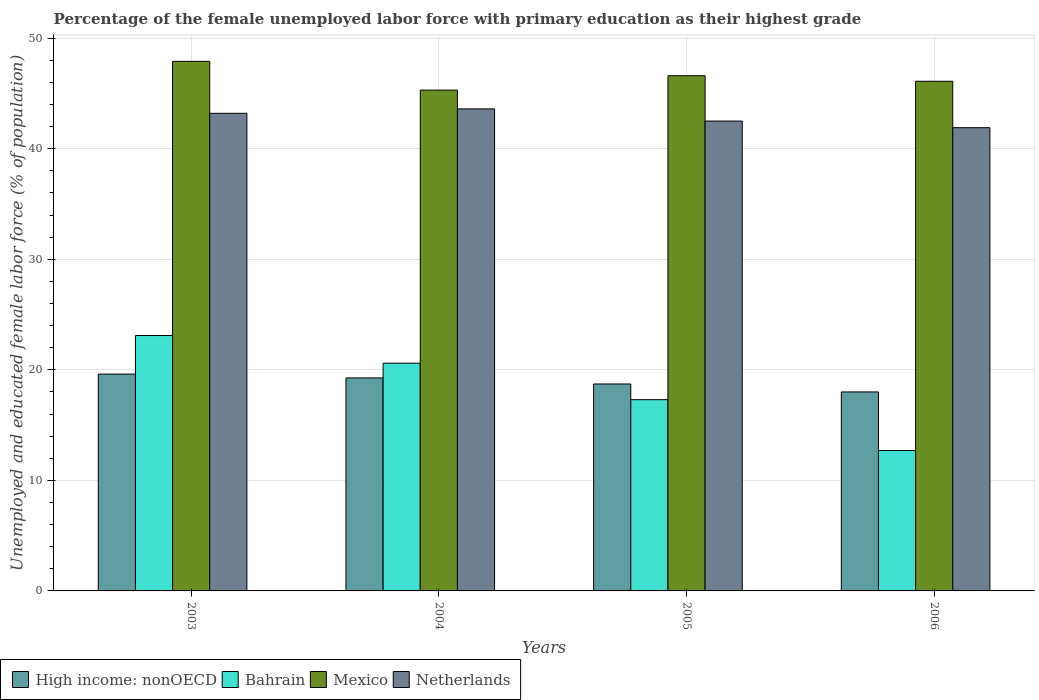How many different coloured bars are there?
Make the answer very short. 4. How many groups of bars are there?
Your response must be concise. 4. Are the number of bars per tick equal to the number of legend labels?
Give a very brief answer. Yes. Are the number of bars on each tick of the X-axis equal?
Give a very brief answer. Yes. How many bars are there on the 2nd tick from the left?
Ensure brevity in your answer.  4. How many bars are there on the 3rd tick from the right?
Your answer should be very brief. 4. What is the label of the 4th group of bars from the left?
Offer a terse response. 2006. In how many cases, is the number of bars for a given year not equal to the number of legend labels?
Your response must be concise. 0. What is the percentage of the unemployed female labor force with primary education in Netherlands in 2004?
Your response must be concise. 43.6. Across all years, what is the maximum percentage of the unemployed female labor force with primary education in Bahrain?
Offer a terse response. 23.1. Across all years, what is the minimum percentage of the unemployed female labor force with primary education in Netherlands?
Your answer should be very brief. 41.9. In which year was the percentage of the unemployed female labor force with primary education in Mexico minimum?
Offer a terse response. 2004. What is the total percentage of the unemployed female labor force with primary education in Mexico in the graph?
Offer a terse response. 185.9. What is the difference between the percentage of the unemployed female labor force with primary education in Netherlands in 2003 and that in 2005?
Ensure brevity in your answer.  0.7. What is the difference between the percentage of the unemployed female labor force with primary education in Mexico in 2005 and the percentage of the unemployed female labor force with primary education in Bahrain in 2003?
Provide a short and direct response. 23.5. What is the average percentage of the unemployed female labor force with primary education in High income: nonOECD per year?
Offer a very short reply. 18.9. In the year 2005, what is the difference between the percentage of the unemployed female labor force with primary education in High income: nonOECD and percentage of the unemployed female labor force with primary education in Netherlands?
Provide a short and direct response. -23.78. What is the ratio of the percentage of the unemployed female labor force with primary education in Bahrain in 2005 to that in 2006?
Offer a very short reply. 1.36. Is the percentage of the unemployed female labor force with primary education in High income: nonOECD in 2004 less than that in 2006?
Your answer should be very brief. No. What is the difference between the highest and the second highest percentage of the unemployed female labor force with primary education in Netherlands?
Provide a short and direct response. 0.4. What is the difference between the highest and the lowest percentage of the unemployed female labor force with primary education in Bahrain?
Your answer should be very brief. 10.4. In how many years, is the percentage of the unemployed female labor force with primary education in Netherlands greater than the average percentage of the unemployed female labor force with primary education in Netherlands taken over all years?
Keep it short and to the point. 2. Is the sum of the percentage of the unemployed female labor force with primary education in Netherlands in 2003 and 2005 greater than the maximum percentage of the unemployed female labor force with primary education in High income: nonOECD across all years?
Offer a very short reply. Yes. What does the 1st bar from the left in 2003 represents?
Your answer should be compact. High income: nonOECD. What does the 4th bar from the right in 2004 represents?
Ensure brevity in your answer.  High income: nonOECD. How many years are there in the graph?
Offer a very short reply. 4. Are the values on the major ticks of Y-axis written in scientific E-notation?
Give a very brief answer. No. Does the graph contain any zero values?
Your answer should be compact. No. How many legend labels are there?
Provide a succinct answer. 4. How are the legend labels stacked?
Give a very brief answer. Horizontal. What is the title of the graph?
Provide a succinct answer. Percentage of the female unemployed labor force with primary education as their highest grade. What is the label or title of the X-axis?
Your answer should be compact. Years. What is the label or title of the Y-axis?
Make the answer very short. Unemployed and educated female labor force (% of population). What is the Unemployed and educated female labor force (% of population) in High income: nonOECD in 2003?
Provide a succinct answer. 19.61. What is the Unemployed and educated female labor force (% of population) in Bahrain in 2003?
Offer a terse response. 23.1. What is the Unemployed and educated female labor force (% of population) in Mexico in 2003?
Provide a succinct answer. 47.9. What is the Unemployed and educated female labor force (% of population) in Netherlands in 2003?
Your answer should be very brief. 43.2. What is the Unemployed and educated female labor force (% of population) in High income: nonOECD in 2004?
Offer a terse response. 19.27. What is the Unemployed and educated female labor force (% of population) of Bahrain in 2004?
Your answer should be compact. 20.6. What is the Unemployed and educated female labor force (% of population) of Mexico in 2004?
Your response must be concise. 45.3. What is the Unemployed and educated female labor force (% of population) in Netherlands in 2004?
Ensure brevity in your answer.  43.6. What is the Unemployed and educated female labor force (% of population) in High income: nonOECD in 2005?
Provide a short and direct response. 18.72. What is the Unemployed and educated female labor force (% of population) in Bahrain in 2005?
Your answer should be compact. 17.3. What is the Unemployed and educated female labor force (% of population) of Mexico in 2005?
Provide a succinct answer. 46.6. What is the Unemployed and educated female labor force (% of population) of Netherlands in 2005?
Your answer should be compact. 42.5. What is the Unemployed and educated female labor force (% of population) of High income: nonOECD in 2006?
Give a very brief answer. 18. What is the Unemployed and educated female labor force (% of population) in Bahrain in 2006?
Make the answer very short. 12.7. What is the Unemployed and educated female labor force (% of population) of Mexico in 2006?
Your answer should be compact. 46.1. What is the Unemployed and educated female labor force (% of population) in Netherlands in 2006?
Your response must be concise. 41.9. Across all years, what is the maximum Unemployed and educated female labor force (% of population) in High income: nonOECD?
Offer a very short reply. 19.61. Across all years, what is the maximum Unemployed and educated female labor force (% of population) in Bahrain?
Provide a succinct answer. 23.1. Across all years, what is the maximum Unemployed and educated female labor force (% of population) in Mexico?
Offer a very short reply. 47.9. Across all years, what is the maximum Unemployed and educated female labor force (% of population) of Netherlands?
Make the answer very short. 43.6. Across all years, what is the minimum Unemployed and educated female labor force (% of population) in High income: nonOECD?
Offer a terse response. 18. Across all years, what is the minimum Unemployed and educated female labor force (% of population) of Bahrain?
Ensure brevity in your answer.  12.7. Across all years, what is the minimum Unemployed and educated female labor force (% of population) of Mexico?
Provide a succinct answer. 45.3. Across all years, what is the minimum Unemployed and educated female labor force (% of population) in Netherlands?
Keep it short and to the point. 41.9. What is the total Unemployed and educated female labor force (% of population) in High income: nonOECD in the graph?
Offer a terse response. 75.59. What is the total Unemployed and educated female labor force (% of population) of Bahrain in the graph?
Make the answer very short. 73.7. What is the total Unemployed and educated female labor force (% of population) in Mexico in the graph?
Keep it short and to the point. 185.9. What is the total Unemployed and educated female labor force (% of population) in Netherlands in the graph?
Your response must be concise. 171.2. What is the difference between the Unemployed and educated female labor force (% of population) in High income: nonOECD in 2003 and that in 2004?
Provide a succinct answer. 0.35. What is the difference between the Unemployed and educated female labor force (% of population) of Mexico in 2003 and that in 2004?
Offer a very short reply. 2.6. What is the difference between the Unemployed and educated female labor force (% of population) in High income: nonOECD in 2003 and that in 2005?
Provide a short and direct response. 0.89. What is the difference between the Unemployed and educated female labor force (% of population) of Mexico in 2003 and that in 2005?
Your answer should be compact. 1.3. What is the difference between the Unemployed and educated female labor force (% of population) of High income: nonOECD in 2003 and that in 2006?
Offer a very short reply. 1.62. What is the difference between the Unemployed and educated female labor force (% of population) of Netherlands in 2003 and that in 2006?
Give a very brief answer. 1.3. What is the difference between the Unemployed and educated female labor force (% of population) of High income: nonOECD in 2004 and that in 2005?
Ensure brevity in your answer.  0.55. What is the difference between the Unemployed and educated female labor force (% of population) of Mexico in 2004 and that in 2005?
Your answer should be compact. -1.3. What is the difference between the Unemployed and educated female labor force (% of population) in Netherlands in 2004 and that in 2005?
Make the answer very short. 1.1. What is the difference between the Unemployed and educated female labor force (% of population) in High income: nonOECD in 2004 and that in 2006?
Offer a very short reply. 1.27. What is the difference between the Unemployed and educated female labor force (% of population) of Mexico in 2004 and that in 2006?
Your answer should be very brief. -0.8. What is the difference between the Unemployed and educated female labor force (% of population) in Netherlands in 2004 and that in 2006?
Make the answer very short. 1.7. What is the difference between the Unemployed and educated female labor force (% of population) of High income: nonOECD in 2005 and that in 2006?
Keep it short and to the point. 0.72. What is the difference between the Unemployed and educated female labor force (% of population) of Bahrain in 2005 and that in 2006?
Provide a short and direct response. 4.6. What is the difference between the Unemployed and educated female labor force (% of population) in Mexico in 2005 and that in 2006?
Your response must be concise. 0.5. What is the difference between the Unemployed and educated female labor force (% of population) of High income: nonOECD in 2003 and the Unemployed and educated female labor force (% of population) of Bahrain in 2004?
Offer a very short reply. -0.99. What is the difference between the Unemployed and educated female labor force (% of population) in High income: nonOECD in 2003 and the Unemployed and educated female labor force (% of population) in Mexico in 2004?
Offer a terse response. -25.69. What is the difference between the Unemployed and educated female labor force (% of population) in High income: nonOECD in 2003 and the Unemployed and educated female labor force (% of population) in Netherlands in 2004?
Ensure brevity in your answer.  -23.99. What is the difference between the Unemployed and educated female labor force (% of population) of Bahrain in 2003 and the Unemployed and educated female labor force (% of population) of Mexico in 2004?
Your response must be concise. -22.2. What is the difference between the Unemployed and educated female labor force (% of population) in Bahrain in 2003 and the Unemployed and educated female labor force (% of population) in Netherlands in 2004?
Your response must be concise. -20.5. What is the difference between the Unemployed and educated female labor force (% of population) of High income: nonOECD in 2003 and the Unemployed and educated female labor force (% of population) of Bahrain in 2005?
Give a very brief answer. 2.31. What is the difference between the Unemployed and educated female labor force (% of population) of High income: nonOECD in 2003 and the Unemployed and educated female labor force (% of population) of Mexico in 2005?
Give a very brief answer. -26.99. What is the difference between the Unemployed and educated female labor force (% of population) in High income: nonOECD in 2003 and the Unemployed and educated female labor force (% of population) in Netherlands in 2005?
Offer a very short reply. -22.89. What is the difference between the Unemployed and educated female labor force (% of population) of Bahrain in 2003 and the Unemployed and educated female labor force (% of population) of Mexico in 2005?
Make the answer very short. -23.5. What is the difference between the Unemployed and educated female labor force (% of population) of Bahrain in 2003 and the Unemployed and educated female labor force (% of population) of Netherlands in 2005?
Keep it short and to the point. -19.4. What is the difference between the Unemployed and educated female labor force (% of population) of Mexico in 2003 and the Unemployed and educated female labor force (% of population) of Netherlands in 2005?
Keep it short and to the point. 5.4. What is the difference between the Unemployed and educated female labor force (% of population) in High income: nonOECD in 2003 and the Unemployed and educated female labor force (% of population) in Bahrain in 2006?
Provide a short and direct response. 6.91. What is the difference between the Unemployed and educated female labor force (% of population) of High income: nonOECD in 2003 and the Unemployed and educated female labor force (% of population) of Mexico in 2006?
Give a very brief answer. -26.49. What is the difference between the Unemployed and educated female labor force (% of population) of High income: nonOECD in 2003 and the Unemployed and educated female labor force (% of population) of Netherlands in 2006?
Offer a very short reply. -22.29. What is the difference between the Unemployed and educated female labor force (% of population) of Bahrain in 2003 and the Unemployed and educated female labor force (% of population) of Mexico in 2006?
Give a very brief answer. -23. What is the difference between the Unemployed and educated female labor force (% of population) of Bahrain in 2003 and the Unemployed and educated female labor force (% of population) of Netherlands in 2006?
Offer a terse response. -18.8. What is the difference between the Unemployed and educated female labor force (% of population) of High income: nonOECD in 2004 and the Unemployed and educated female labor force (% of population) of Bahrain in 2005?
Provide a succinct answer. 1.97. What is the difference between the Unemployed and educated female labor force (% of population) of High income: nonOECD in 2004 and the Unemployed and educated female labor force (% of population) of Mexico in 2005?
Your answer should be compact. -27.33. What is the difference between the Unemployed and educated female labor force (% of population) of High income: nonOECD in 2004 and the Unemployed and educated female labor force (% of population) of Netherlands in 2005?
Provide a succinct answer. -23.23. What is the difference between the Unemployed and educated female labor force (% of population) of Bahrain in 2004 and the Unemployed and educated female labor force (% of population) of Netherlands in 2005?
Make the answer very short. -21.9. What is the difference between the Unemployed and educated female labor force (% of population) in High income: nonOECD in 2004 and the Unemployed and educated female labor force (% of population) in Bahrain in 2006?
Give a very brief answer. 6.57. What is the difference between the Unemployed and educated female labor force (% of population) in High income: nonOECD in 2004 and the Unemployed and educated female labor force (% of population) in Mexico in 2006?
Your answer should be very brief. -26.83. What is the difference between the Unemployed and educated female labor force (% of population) in High income: nonOECD in 2004 and the Unemployed and educated female labor force (% of population) in Netherlands in 2006?
Provide a succinct answer. -22.63. What is the difference between the Unemployed and educated female labor force (% of population) of Bahrain in 2004 and the Unemployed and educated female labor force (% of population) of Mexico in 2006?
Your answer should be very brief. -25.5. What is the difference between the Unemployed and educated female labor force (% of population) in Bahrain in 2004 and the Unemployed and educated female labor force (% of population) in Netherlands in 2006?
Give a very brief answer. -21.3. What is the difference between the Unemployed and educated female labor force (% of population) in High income: nonOECD in 2005 and the Unemployed and educated female labor force (% of population) in Bahrain in 2006?
Your answer should be very brief. 6.02. What is the difference between the Unemployed and educated female labor force (% of population) in High income: nonOECD in 2005 and the Unemployed and educated female labor force (% of population) in Mexico in 2006?
Provide a short and direct response. -27.38. What is the difference between the Unemployed and educated female labor force (% of population) in High income: nonOECD in 2005 and the Unemployed and educated female labor force (% of population) in Netherlands in 2006?
Offer a very short reply. -23.18. What is the difference between the Unemployed and educated female labor force (% of population) of Bahrain in 2005 and the Unemployed and educated female labor force (% of population) of Mexico in 2006?
Offer a terse response. -28.8. What is the difference between the Unemployed and educated female labor force (% of population) in Bahrain in 2005 and the Unemployed and educated female labor force (% of population) in Netherlands in 2006?
Give a very brief answer. -24.6. What is the average Unemployed and educated female labor force (% of population) in High income: nonOECD per year?
Provide a short and direct response. 18.9. What is the average Unemployed and educated female labor force (% of population) in Bahrain per year?
Offer a terse response. 18.43. What is the average Unemployed and educated female labor force (% of population) of Mexico per year?
Your response must be concise. 46.48. What is the average Unemployed and educated female labor force (% of population) in Netherlands per year?
Your answer should be very brief. 42.8. In the year 2003, what is the difference between the Unemployed and educated female labor force (% of population) of High income: nonOECD and Unemployed and educated female labor force (% of population) of Bahrain?
Provide a short and direct response. -3.49. In the year 2003, what is the difference between the Unemployed and educated female labor force (% of population) of High income: nonOECD and Unemployed and educated female labor force (% of population) of Mexico?
Your response must be concise. -28.29. In the year 2003, what is the difference between the Unemployed and educated female labor force (% of population) in High income: nonOECD and Unemployed and educated female labor force (% of population) in Netherlands?
Your answer should be compact. -23.59. In the year 2003, what is the difference between the Unemployed and educated female labor force (% of population) of Bahrain and Unemployed and educated female labor force (% of population) of Mexico?
Give a very brief answer. -24.8. In the year 2003, what is the difference between the Unemployed and educated female labor force (% of population) in Bahrain and Unemployed and educated female labor force (% of population) in Netherlands?
Ensure brevity in your answer.  -20.1. In the year 2004, what is the difference between the Unemployed and educated female labor force (% of population) in High income: nonOECD and Unemployed and educated female labor force (% of population) in Bahrain?
Keep it short and to the point. -1.33. In the year 2004, what is the difference between the Unemployed and educated female labor force (% of population) in High income: nonOECD and Unemployed and educated female labor force (% of population) in Mexico?
Ensure brevity in your answer.  -26.03. In the year 2004, what is the difference between the Unemployed and educated female labor force (% of population) of High income: nonOECD and Unemployed and educated female labor force (% of population) of Netherlands?
Offer a terse response. -24.33. In the year 2004, what is the difference between the Unemployed and educated female labor force (% of population) of Bahrain and Unemployed and educated female labor force (% of population) of Mexico?
Make the answer very short. -24.7. In the year 2004, what is the difference between the Unemployed and educated female labor force (% of population) in Mexico and Unemployed and educated female labor force (% of population) in Netherlands?
Your response must be concise. 1.7. In the year 2005, what is the difference between the Unemployed and educated female labor force (% of population) in High income: nonOECD and Unemployed and educated female labor force (% of population) in Bahrain?
Your answer should be compact. 1.42. In the year 2005, what is the difference between the Unemployed and educated female labor force (% of population) in High income: nonOECD and Unemployed and educated female labor force (% of population) in Mexico?
Offer a terse response. -27.88. In the year 2005, what is the difference between the Unemployed and educated female labor force (% of population) in High income: nonOECD and Unemployed and educated female labor force (% of population) in Netherlands?
Your response must be concise. -23.78. In the year 2005, what is the difference between the Unemployed and educated female labor force (% of population) of Bahrain and Unemployed and educated female labor force (% of population) of Mexico?
Your response must be concise. -29.3. In the year 2005, what is the difference between the Unemployed and educated female labor force (% of population) in Bahrain and Unemployed and educated female labor force (% of population) in Netherlands?
Your answer should be very brief. -25.2. In the year 2005, what is the difference between the Unemployed and educated female labor force (% of population) in Mexico and Unemployed and educated female labor force (% of population) in Netherlands?
Ensure brevity in your answer.  4.1. In the year 2006, what is the difference between the Unemployed and educated female labor force (% of population) of High income: nonOECD and Unemployed and educated female labor force (% of population) of Bahrain?
Offer a very short reply. 5.3. In the year 2006, what is the difference between the Unemployed and educated female labor force (% of population) in High income: nonOECD and Unemployed and educated female labor force (% of population) in Mexico?
Offer a very short reply. -28.1. In the year 2006, what is the difference between the Unemployed and educated female labor force (% of population) in High income: nonOECD and Unemployed and educated female labor force (% of population) in Netherlands?
Offer a terse response. -23.9. In the year 2006, what is the difference between the Unemployed and educated female labor force (% of population) of Bahrain and Unemployed and educated female labor force (% of population) of Mexico?
Your answer should be very brief. -33.4. In the year 2006, what is the difference between the Unemployed and educated female labor force (% of population) in Bahrain and Unemployed and educated female labor force (% of population) in Netherlands?
Your answer should be very brief. -29.2. What is the ratio of the Unemployed and educated female labor force (% of population) of High income: nonOECD in 2003 to that in 2004?
Provide a succinct answer. 1.02. What is the ratio of the Unemployed and educated female labor force (% of population) of Bahrain in 2003 to that in 2004?
Provide a succinct answer. 1.12. What is the ratio of the Unemployed and educated female labor force (% of population) in Mexico in 2003 to that in 2004?
Your answer should be very brief. 1.06. What is the ratio of the Unemployed and educated female labor force (% of population) of Netherlands in 2003 to that in 2004?
Your answer should be compact. 0.99. What is the ratio of the Unemployed and educated female labor force (% of population) in High income: nonOECD in 2003 to that in 2005?
Your response must be concise. 1.05. What is the ratio of the Unemployed and educated female labor force (% of population) of Bahrain in 2003 to that in 2005?
Keep it short and to the point. 1.34. What is the ratio of the Unemployed and educated female labor force (% of population) in Mexico in 2003 to that in 2005?
Provide a succinct answer. 1.03. What is the ratio of the Unemployed and educated female labor force (% of population) in Netherlands in 2003 to that in 2005?
Your response must be concise. 1.02. What is the ratio of the Unemployed and educated female labor force (% of population) of High income: nonOECD in 2003 to that in 2006?
Provide a succinct answer. 1.09. What is the ratio of the Unemployed and educated female labor force (% of population) in Bahrain in 2003 to that in 2006?
Provide a succinct answer. 1.82. What is the ratio of the Unemployed and educated female labor force (% of population) of Mexico in 2003 to that in 2006?
Provide a succinct answer. 1.04. What is the ratio of the Unemployed and educated female labor force (% of population) of Netherlands in 2003 to that in 2006?
Provide a succinct answer. 1.03. What is the ratio of the Unemployed and educated female labor force (% of population) of High income: nonOECD in 2004 to that in 2005?
Make the answer very short. 1.03. What is the ratio of the Unemployed and educated female labor force (% of population) in Bahrain in 2004 to that in 2005?
Provide a succinct answer. 1.19. What is the ratio of the Unemployed and educated female labor force (% of population) of Mexico in 2004 to that in 2005?
Your answer should be compact. 0.97. What is the ratio of the Unemployed and educated female labor force (% of population) of Netherlands in 2004 to that in 2005?
Give a very brief answer. 1.03. What is the ratio of the Unemployed and educated female labor force (% of population) of High income: nonOECD in 2004 to that in 2006?
Offer a terse response. 1.07. What is the ratio of the Unemployed and educated female labor force (% of population) in Bahrain in 2004 to that in 2006?
Ensure brevity in your answer.  1.62. What is the ratio of the Unemployed and educated female labor force (% of population) of Mexico in 2004 to that in 2006?
Give a very brief answer. 0.98. What is the ratio of the Unemployed and educated female labor force (% of population) in Netherlands in 2004 to that in 2006?
Provide a succinct answer. 1.04. What is the ratio of the Unemployed and educated female labor force (% of population) of High income: nonOECD in 2005 to that in 2006?
Ensure brevity in your answer.  1.04. What is the ratio of the Unemployed and educated female labor force (% of population) in Bahrain in 2005 to that in 2006?
Your answer should be compact. 1.36. What is the ratio of the Unemployed and educated female labor force (% of population) in Mexico in 2005 to that in 2006?
Ensure brevity in your answer.  1.01. What is the ratio of the Unemployed and educated female labor force (% of population) in Netherlands in 2005 to that in 2006?
Offer a very short reply. 1.01. What is the difference between the highest and the second highest Unemployed and educated female labor force (% of population) of High income: nonOECD?
Offer a very short reply. 0.35. What is the difference between the highest and the second highest Unemployed and educated female labor force (% of population) in Mexico?
Your response must be concise. 1.3. What is the difference between the highest and the lowest Unemployed and educated female labor force (% of population) of High income: nonOECD?
Your answer should be compact. 1.62. What is the difference between the highest and the lowest Unemployed and educated female labor force (% of population) of Bahrain?
Ensure brevity in your answer.  10.4. What is the difference between the highest and the lowest Unemployed and educated female labor force (% of population) in Mexico?
Offer a very short reply. 2.6. 